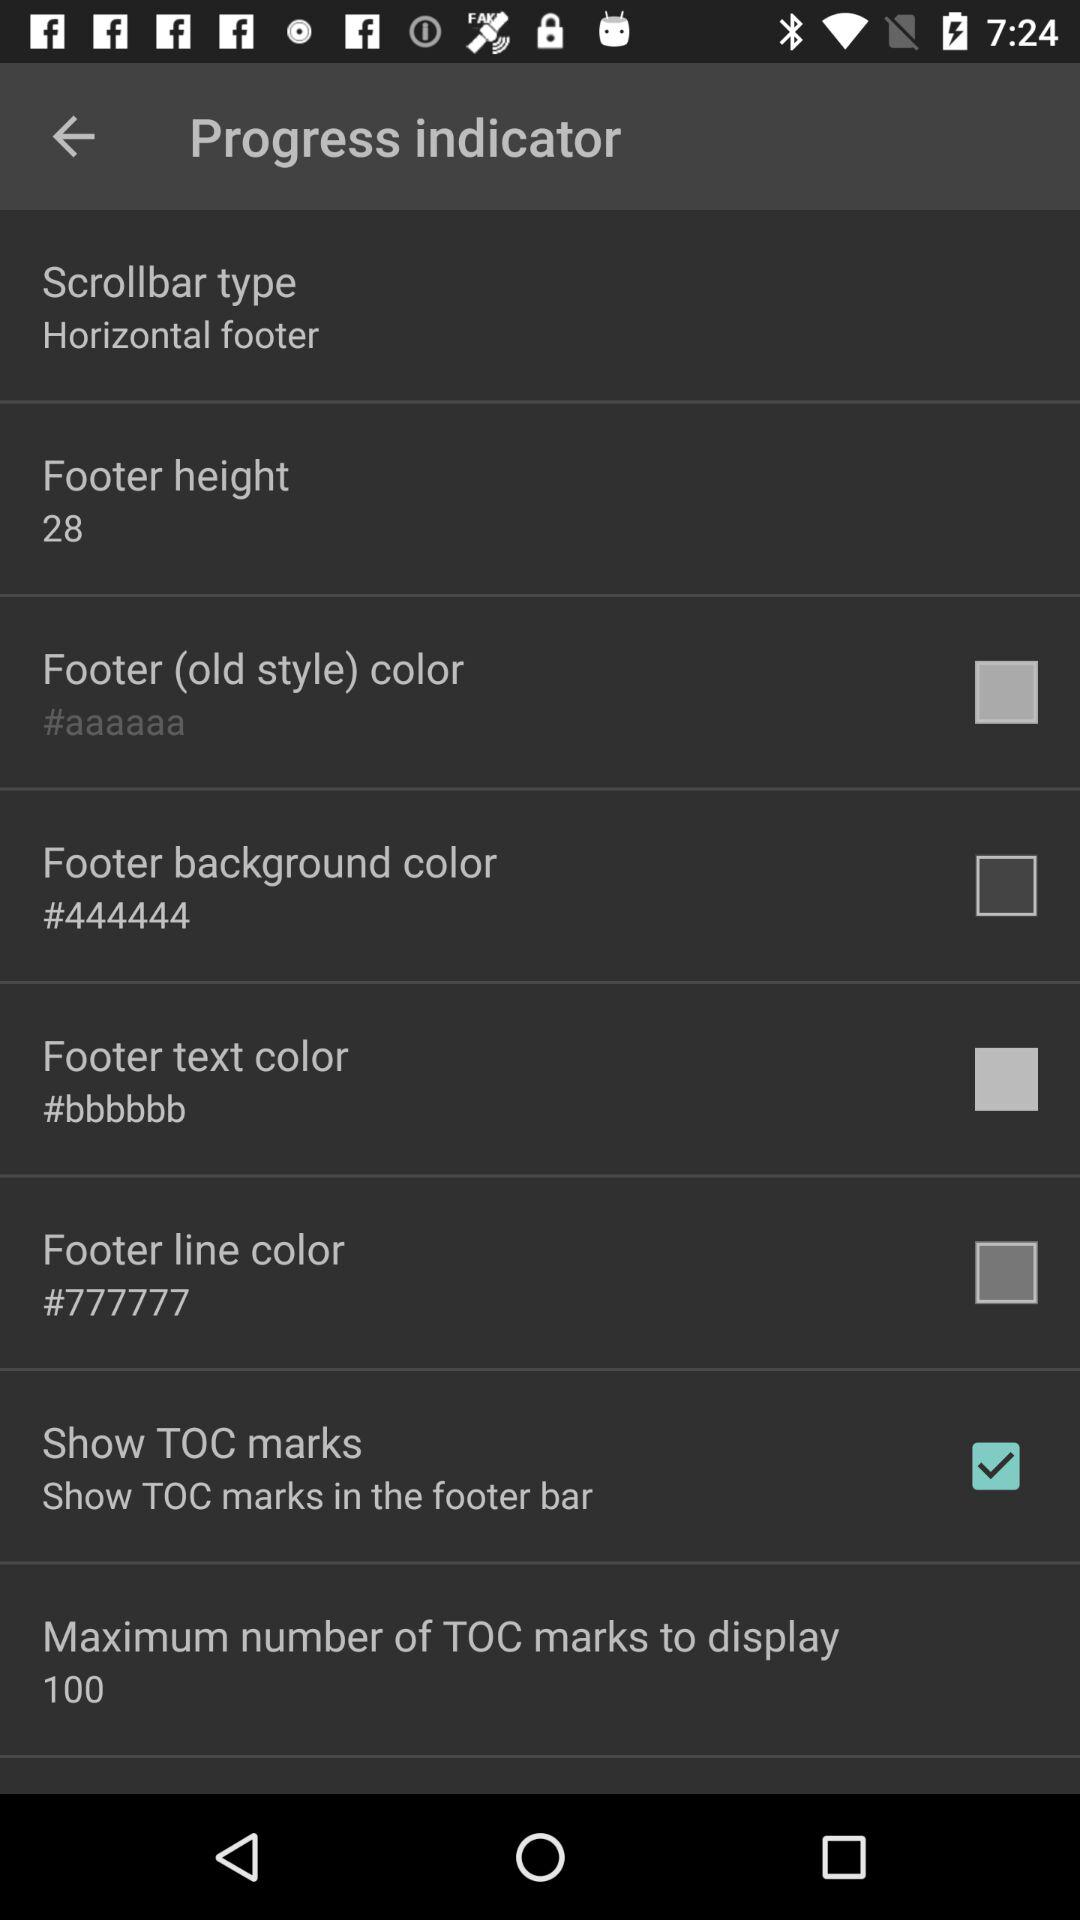What is the type of scrolbar? The scrollbar type is horizontal footer. 